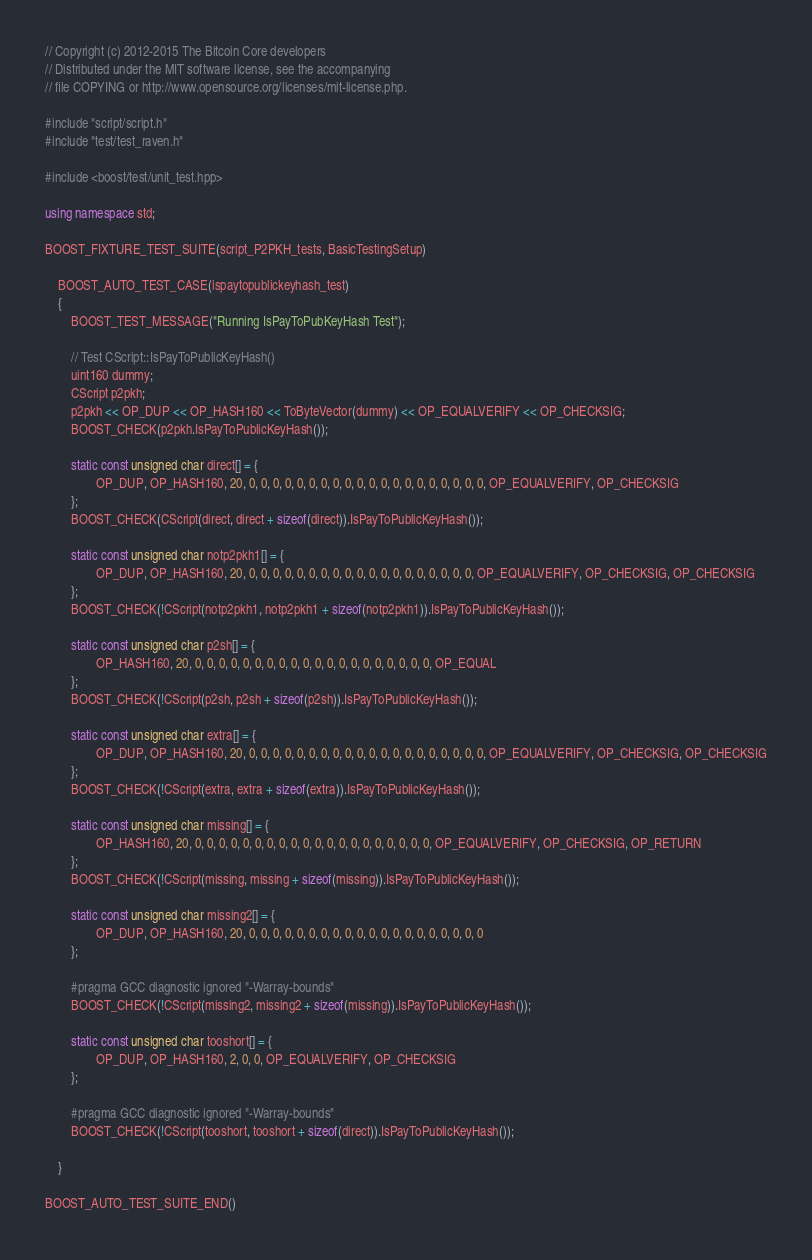Convert code to text. <code><loc_0><loc_0><loc_500><loc_500><_C++_>// Copyright (c) 2012-2015 The Bitcoin Core developers
// Distributed under the MIT software license, see the accompanying
// file COPYING or http://www.opensource.org/licenses/mit-license.php.

#include "script/script.h"
#include "test/test_raven.h"

#include <boost/test/unit_test.hpp>

using namespace std;

BOOST_FIXTURE_TEST_SUITE(script_P2PKH_tests, BasicTestingSetup)

    BOOST_AUTO_TEST_CASE(ispaytopublickeyhash_test)
    {
        BOOST_TEST_MESSAGE("Running IsPayToPubKeyHash Test");

        // Test CScript::IsPayToPublicKeyHash()
        uint160 dummy;
        CScript p2pkh;
        p2pkh << OP_DUP << OP_HASH160 << ToByteVector(dummy) << OP_EQUALVERIFY << OP_CHECKSIG;
        BOOST_CHECK(p2pkh.IsPayToPublicKeyHash());

        static const unsigned char direct[] = {
                OP_DUP, OP_HASH160, 20, 0, 0, 0, 0, 0, 0, 0, 0, 0, 0, 0, 0, 0, 0, 0, 0, 0, 0, 0, 0, OP_EQUALVERIFY, OP_CHECKSIG
        };
        BOOST_CHECK(CScript(direct, direct + sizeof(direct)).IsPayToPublicKeyHash());

        static const unsigned char notp2pkh1[] = {
                OP_DUP, OP_HASH160, 20, 0, 0, 0, 0, 0, 0, 0, 0, 0, 0, 0, 0, 0, 0, 0, 0, 0, 0, 0, OP_EQUALVERIFY, OP_CHECKSIG, OP_CHECKSIG
        };
        BOOST_CHECK(!CScript(notp2pkh1, notp2pkh1 + sizeof(notp2pkh1)).IsPayToPublicKeyHash());

        static const unsigned char p2sh[] = {
                OP_HASH160, 20, 0, 0, 0, 0, 0, 0, 0, 0, 0, 0, 0, 0, 0, 0, 0, 0, 0, 0, 0, 0, OP_EQUAL
        };
        BOOST_CHECK(!CScript(p2sh, p2sh + sizeof(p2sh)).IsPayToPublicKeyHash());

        static const unsigned char extra[] = {
                OP_DUP, OP_HASH160, 20, 0, 0, 0, 0, 0, 0, 0, 0, 0, 0, 0, 0, 0, 0, 0, 0, 0, 0, 0, 0, OP_EQUALVERIFY, OP_CHECKSIG, OP_CHECKSIG
        };
        BOOST_CHECK(!CScript(extra, extra + sizeof(extra)).IsPayToPublicKeyHash());

        static const unsigned char missing[] = {
                OP_HASH160, 20, 0, 0, 0, 0, 0, 0, 0, 0, 0, 0, 0, 0, 0, 0, 0, 0, 0, 0, 0, 0, OP_EQUALVERIFY, OP_CHECKSIG, OP_RETURN
        };
        BOOST_CHECK(!CScript(missing, missing + sizeof(missing)).IsPayToPublicKeyHash());

        static const unsigned char missing2[] = {
                OP_DUP, OP_HASH160, 20, 0, 0, 0, 0, 0, 0, 0, 0, 0, 0, 0, 0, 0, 0, 0, 0, 0, 0, 0, 0
        };

        #pragma GCC diagnostic ignored "-Warray-bounds"
        BOOST_CHECK(!CScript(missing2, missing2 + sizeof(missing)).IsPayToPublicKeyHash());

        static const unsigned char tooshort[] = {
                OP_DUP, OP_HASH160, 2, 0, 0, OP_EQUALVERIFY, OP_CHECKSIG
        };

        #pragma GCC diagnostic ignored "-Warray-bounds"
        BOOST_CHECK(!CScript(tooshort, tooshort + sizeof(direct)).IsPayToPublicKeyHash());

    }

BOOST_AUTO_TEST_SUITE_END()
</code> 